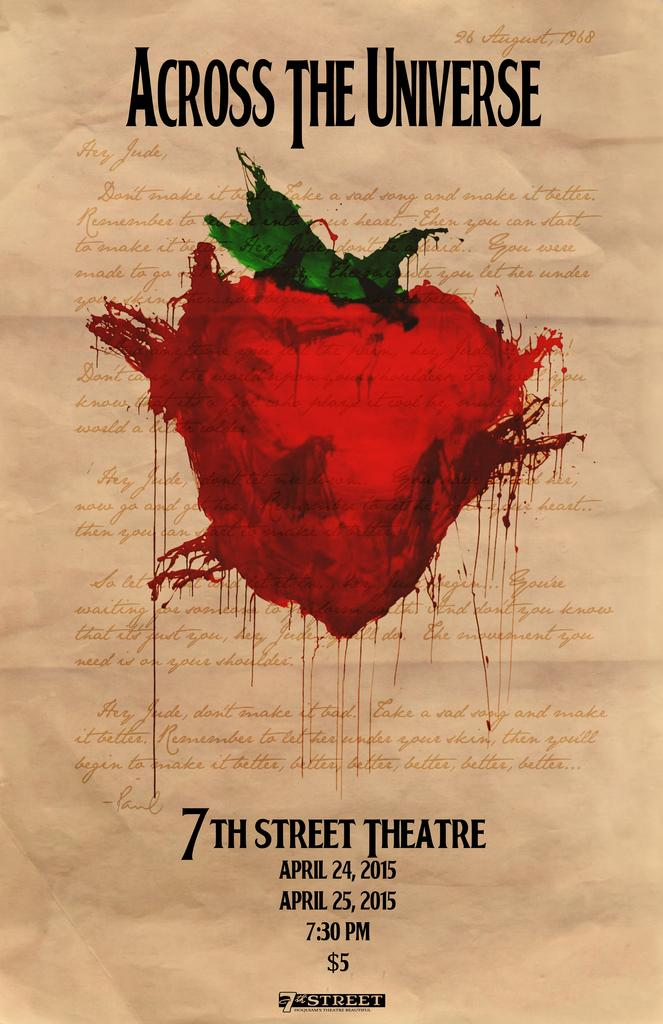<image>
Describe the image concisely. a theatre poster that is titled 'across the universe' 